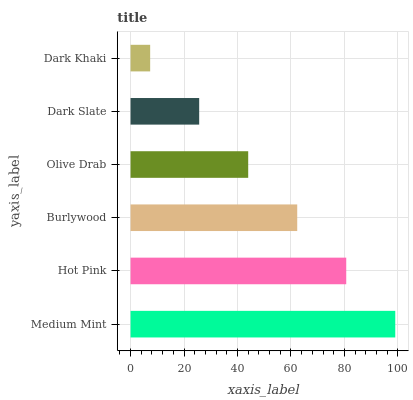Is Dark Khaki the minimum?
Answer yes or no. Yes. Is Medium Mint the maximum?
Answer yes or no. Yes. Is Hot Pink the minimum?
Answer yes or no. No. Is Hot Pink the maximum?
Answer yes or no. No. Is Medium Mint greater than Hot Pink?
Answer yes or no. Yes. Is Hot Pink less than Medium Mint?
Answer yes or no. Yes. Is Hot Pink greater than Medium Mint?
Answer yes or no. No. Is Medium Mint less than Hot Pink?
Answer yes or no. No. Is Burlywood the high median?
Answer yes or no. Yes. Is Olive Drab the low median?
Answer yes or no. Yes. Is Dark Slate the high median?
Answer yes or no. No. Is Dark Slate the low median?
Answer yes or no. No. 